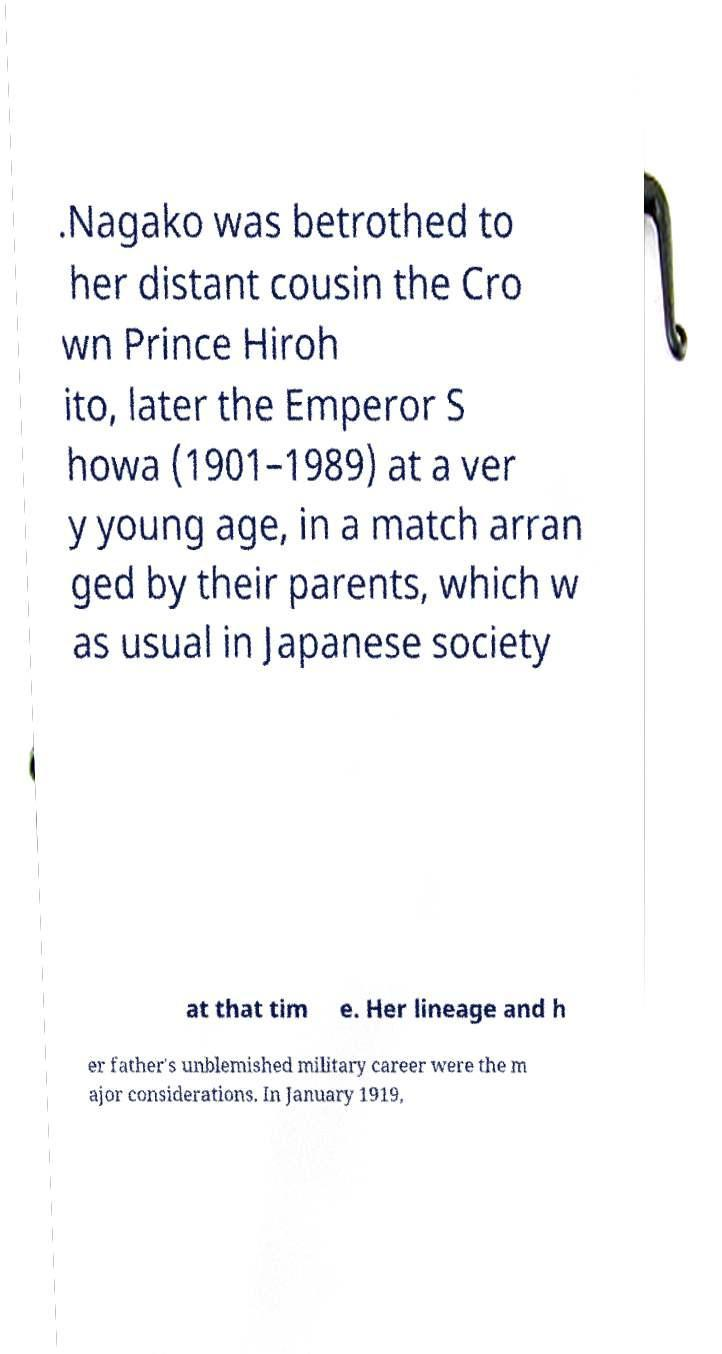Can you accurately transcribe the text from the provided image for me? .Nagako was betrothed to her distant cousin the Cro wn Prince Hiroh ito, later the Emperor S howa (1901–1989) at a ver y young age, in a match arran ged by their parents, which w as usual in Japanese society at that tim e. Her lineage and h er father's unblemished military career were the m ajor considerations. In January 1919, 